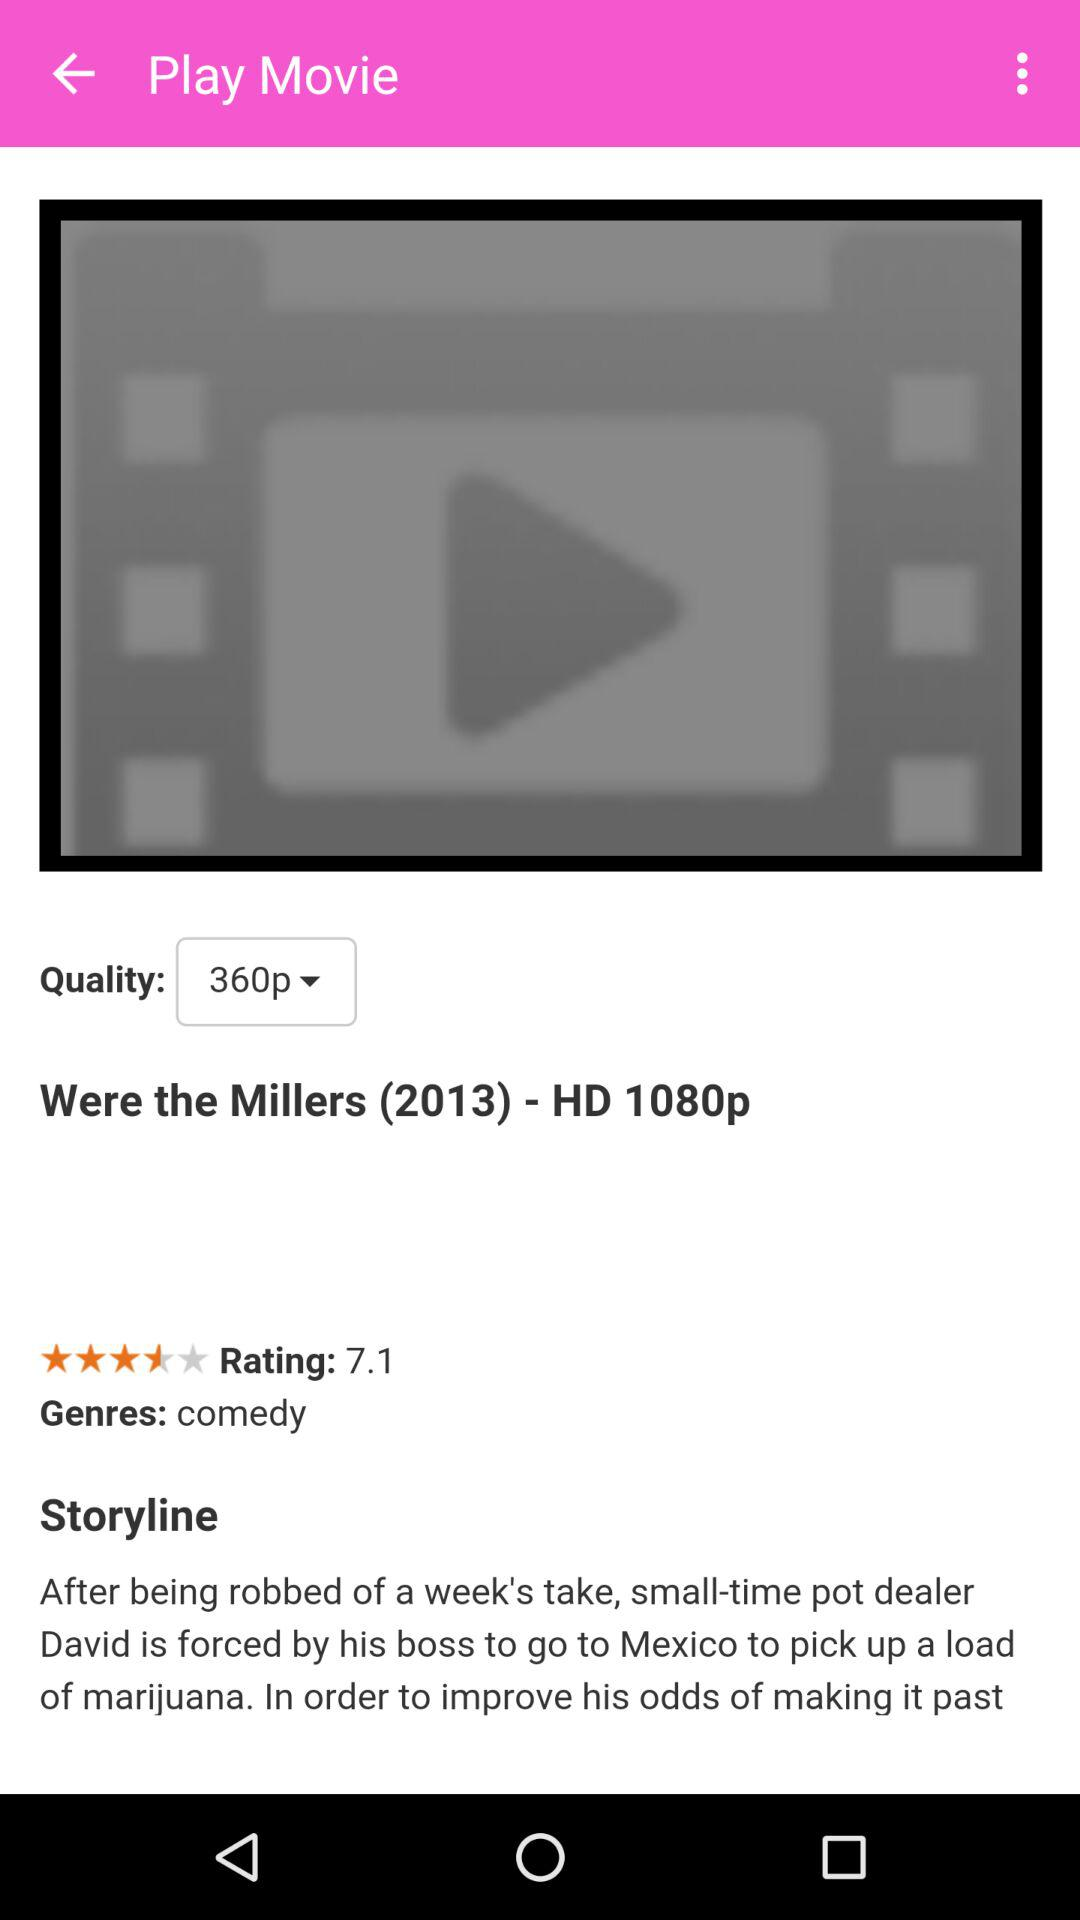What is the selected quality? The selected quality is 360p. 